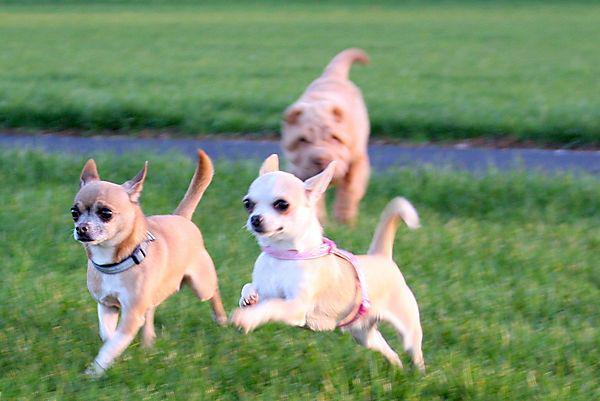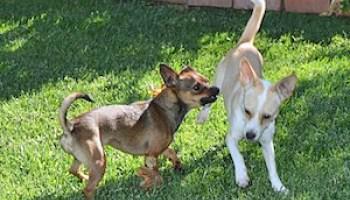The first image is the image on the left, the second image is the image on the right. Analyze the images presented: Is the assertion "Left image features two small dogs with no collars or leashes." valid? Answer yes or no. No. The first image is the image on the left, the second image is the image on the right. Analyze the images presented: Is the assertion "One dog's tail is fluffy." valid? Answer yes or no. No. 